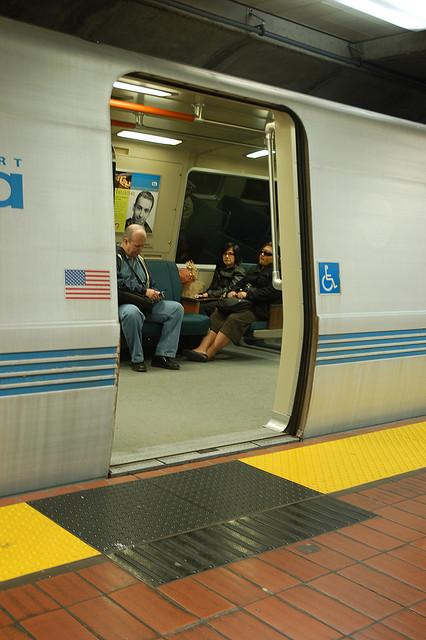What has the train indicated it is accessible to?

Choices:
A) planes
B) cars
C) bikes
D) wheelchairs wheelchairs 